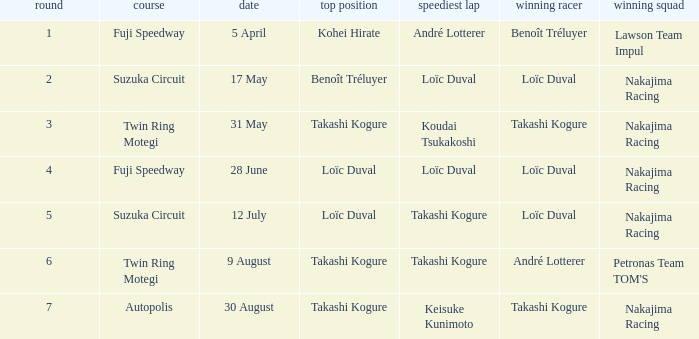What was the earlier round where Takashi Kogure got the fastest lap? 5.0. 